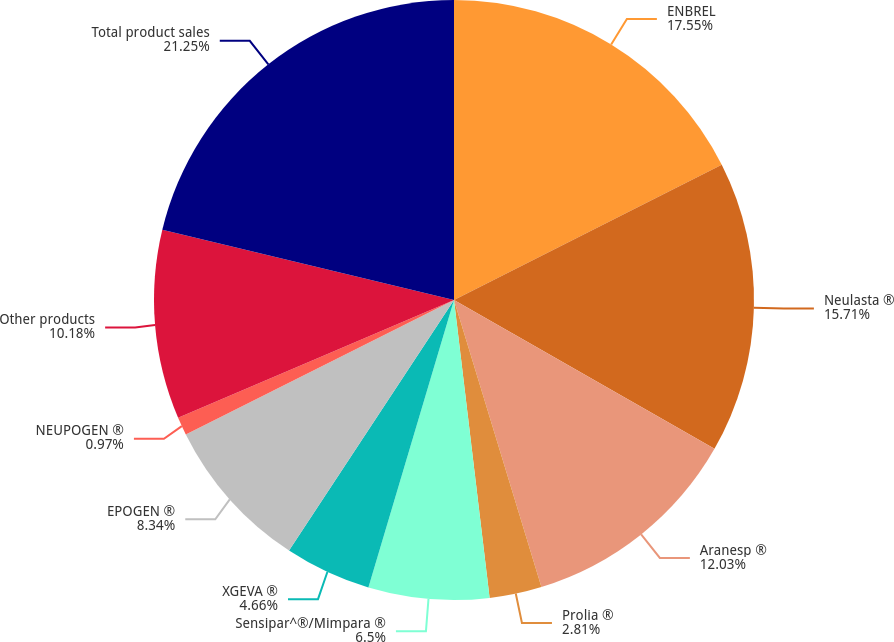<chart> <loc_0><loc_0><loc_500><loc_500><pie_chart><fcel>ENBREL<fcel>Neulasta ®<fcel>Aranesp ®<fcel>Prolia ®<fcel>Sensipar^®/Mimpara ®<fcel>XGEVA ®<fcel>EPOGEN ®<fcel>NEUPOGEN ®<fcel>Other products<fcel>Total product sales<nl><fcel>17.55%<fcel>15.71%<fcel>12.03%<fcel>2.81%<fcel>6.5%<fcel>4.66%<fcel>8.34%<fcel>0.97%<fcel>10.18%<fcel>21.24%<nl></chart> 